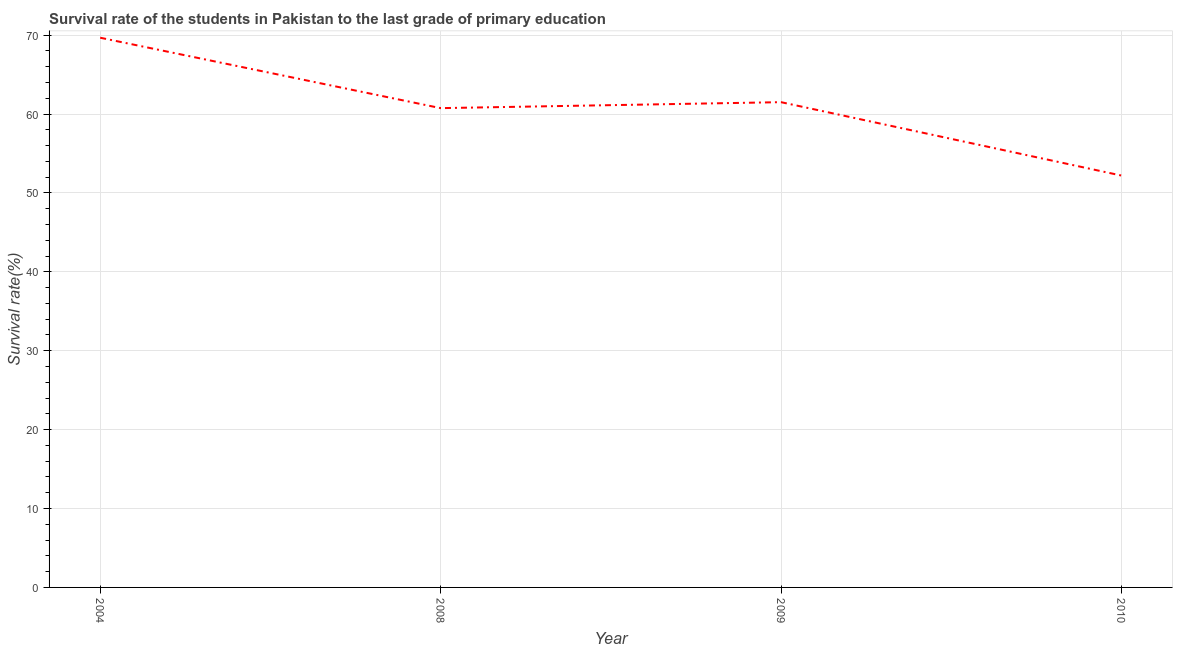What is the survival rate in primary education in 2010?
Keep it short and to the point. 52.21. Across all years, what is the maximum survival rate in primary education?
Offer a very short reply. 69.68. Across all years, what is the minimum survival rate in primary education?
Keep it short and to the point. 52.21. What is the sum of the survival rate in primary education?
Keep it short and to the point. 244.14. What is the difference between the survival rate in primary education in 2008 and 2009?
Your answer should be very brief. -0.76. What is the average survival rate in primary education per year?
Your answer should be very brief. 61.04. What is the median survival rate in primary education?
Make the answer very short. 61.13. In how many years, is the survival rate in primary education greater than 10 %?
Ensure brevity in your answer.  4. What is the ratio of the survival rate in primary education in 2009 to that in 2010?
Your response must be concise. 1.18. Is the survival rate in primary education in 2004 less than that in 2009?
Provide a succinct answer. No. Is the difference between the survival rate in primary education in 2008 and 2009 greater than the difference between any two years?
Give a very brief answer. No. What is the difference between the highest and the second highest survival rate in primary education?
Give a very brief answer. 8.17. What is the difference between the highest and the lowest survival rate in primary education?
Your answer should be compact. 17.47. How many years are there in the graph?
Give a very brief answer. 4. Are the values on the major ticks of Y-axis written in scientific E-notation?
Make the answer very short. No. Does the graph contain grids?
Make the answer very short. Yes. What is the title of the graph?
Offer a terse response. Survival rate of the students in Pakistan to the last grade of primary education. What is the label or title of the Y-axis?
Ensure brevity in your answer.  Survival rate(%). What is the Survival rate(%) in 2004?
Provide a succinct answer. 69.68. What is the Survival rate(%) in 2008?
Your answer should be compact. 60.75. What is the Survival rate(%) in 2009?
Offer a very short reply. 61.51. What is the Survival rate(%) in 2010?
Provide a short and direct response. 52.21. What is the difference between the Survival rate(%) in 2004 and 2008?
Give a very brief answer. 8.93. What is the difference between the Survival rate(%) in 2004 and 2009?
Provide a succinct answer. 8.17. What is the difference between the Survival rate(%) in 2004 and 2010?
Provide a short and direct response. 17.47. What is the difference between the Survival rate(%) in 2008 and 2009?
Your answer should be very brief. -0.76. What is the difference between the Survival rate(%) in 2008 and 2010?
Your answer should be very brief. 8.55. What is the difference between the Survival rate(%) in 2009 and 2010?
Make the answer very short. 9.3. What is the ratio of the Survival rate(%) in 2004 to that in 2008?
Offer a very short reply. 1.15. What is the ratio of the Survival rate(%) in 2004 to that in 2009?
Your answer should be very brief. 1.13. What is the ratio of the Survival rate(%) in 2004 to that in 2010?
Ensure brevity in your answer.  1.33. What is the ratio of the Survival rate(%) in 2008 to that in 2009?
Your response must be concise. 0.99. What is the ratio of the Survival rate(%) in 2008 to that in 2010?
Your answer should be compact. 1.16. What is the ratio of the Survival rate(%) in 2009 to that in 2010?
Ensure brevity in your answer.  1.18. 